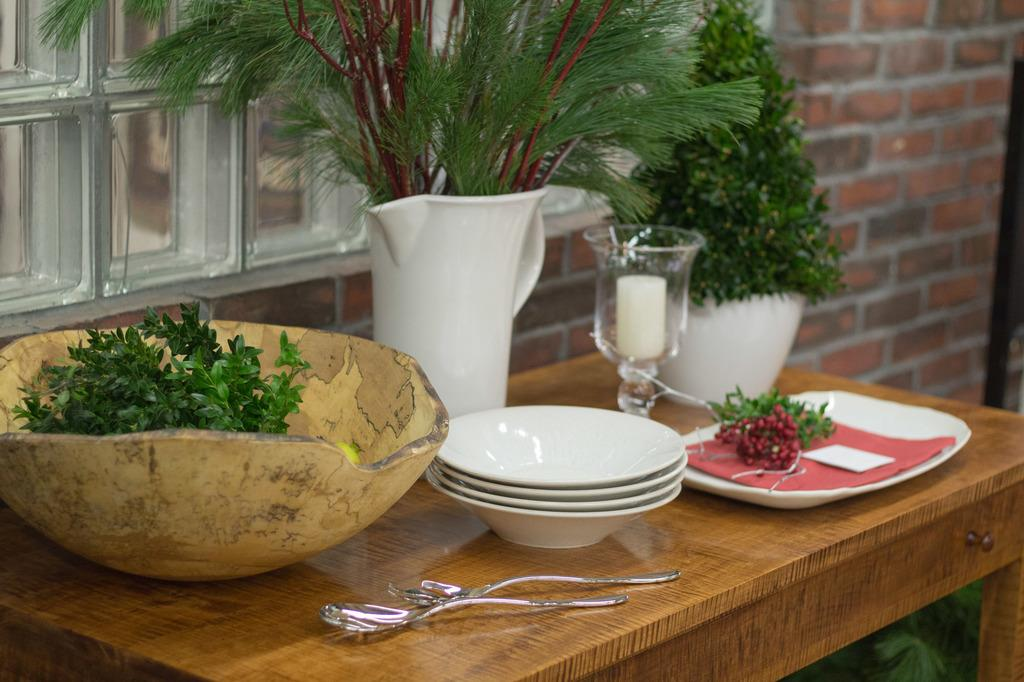What is the main object in the center of the image? There is a table in the center of the image. What items can be found on the table? On the table, there is a bowl, a flower vase, a plant, a plate, a paper, a glass, a mug, a spoon, and a fork. What can be seen in the background of the image? There is a wall and a window in the background of the image. What country is being shown in the image? The image does not depict a specific country; it only shows a table with various items and a background with a wall and a window. 